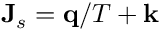Convert formula to latex. <formula><loc_0><loc_0><loc_500><loc_500>\mathbf J _ { s } = \mathbf q / T + \mathbf k</formula> 